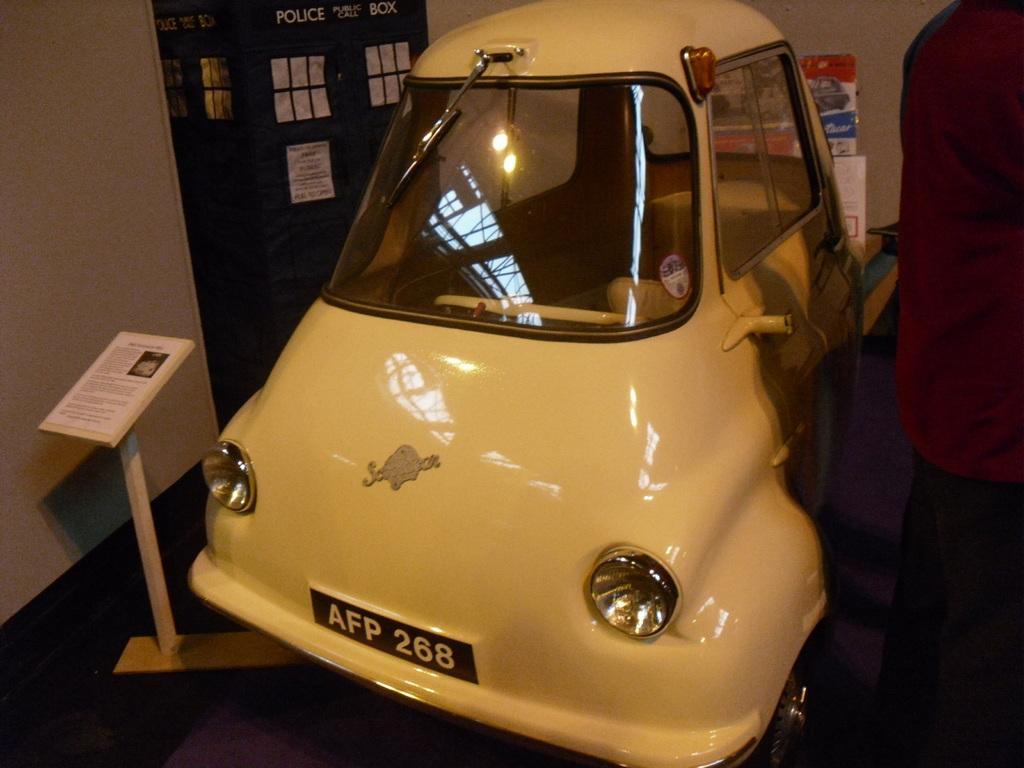Can you describe this image briefly? In this image I can see the car which is in yellow color. To the right there is a person standing and wearing the maroon and black color dress. To the left I can see the board. In the background I can see the banners and the boards to the wall. 